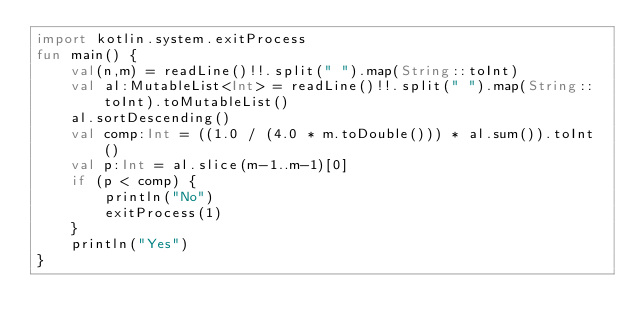<code> <loc_0><loc_0><loc_500><loc_500><_Kotlin_>import kotlin.system.exitProcess
fun main() {
    val(n,m) = readLine()!!.split(" ").map(String::toInt)
    val al:MutableList<Int> = readLine()!!.split(" ").map(String::toInt).toMutableList()
    al.sortDescending()
    val comp:Int = ((1.0 / (4.0 * m.toDouble())) * al.sum()).toInt()
    val p:Int = al.slice(m-1..m-1)[0]
    if (p < comp) {
        println("No")
        exitProcess(1)
    }
    println("Yes")
}
</code> 